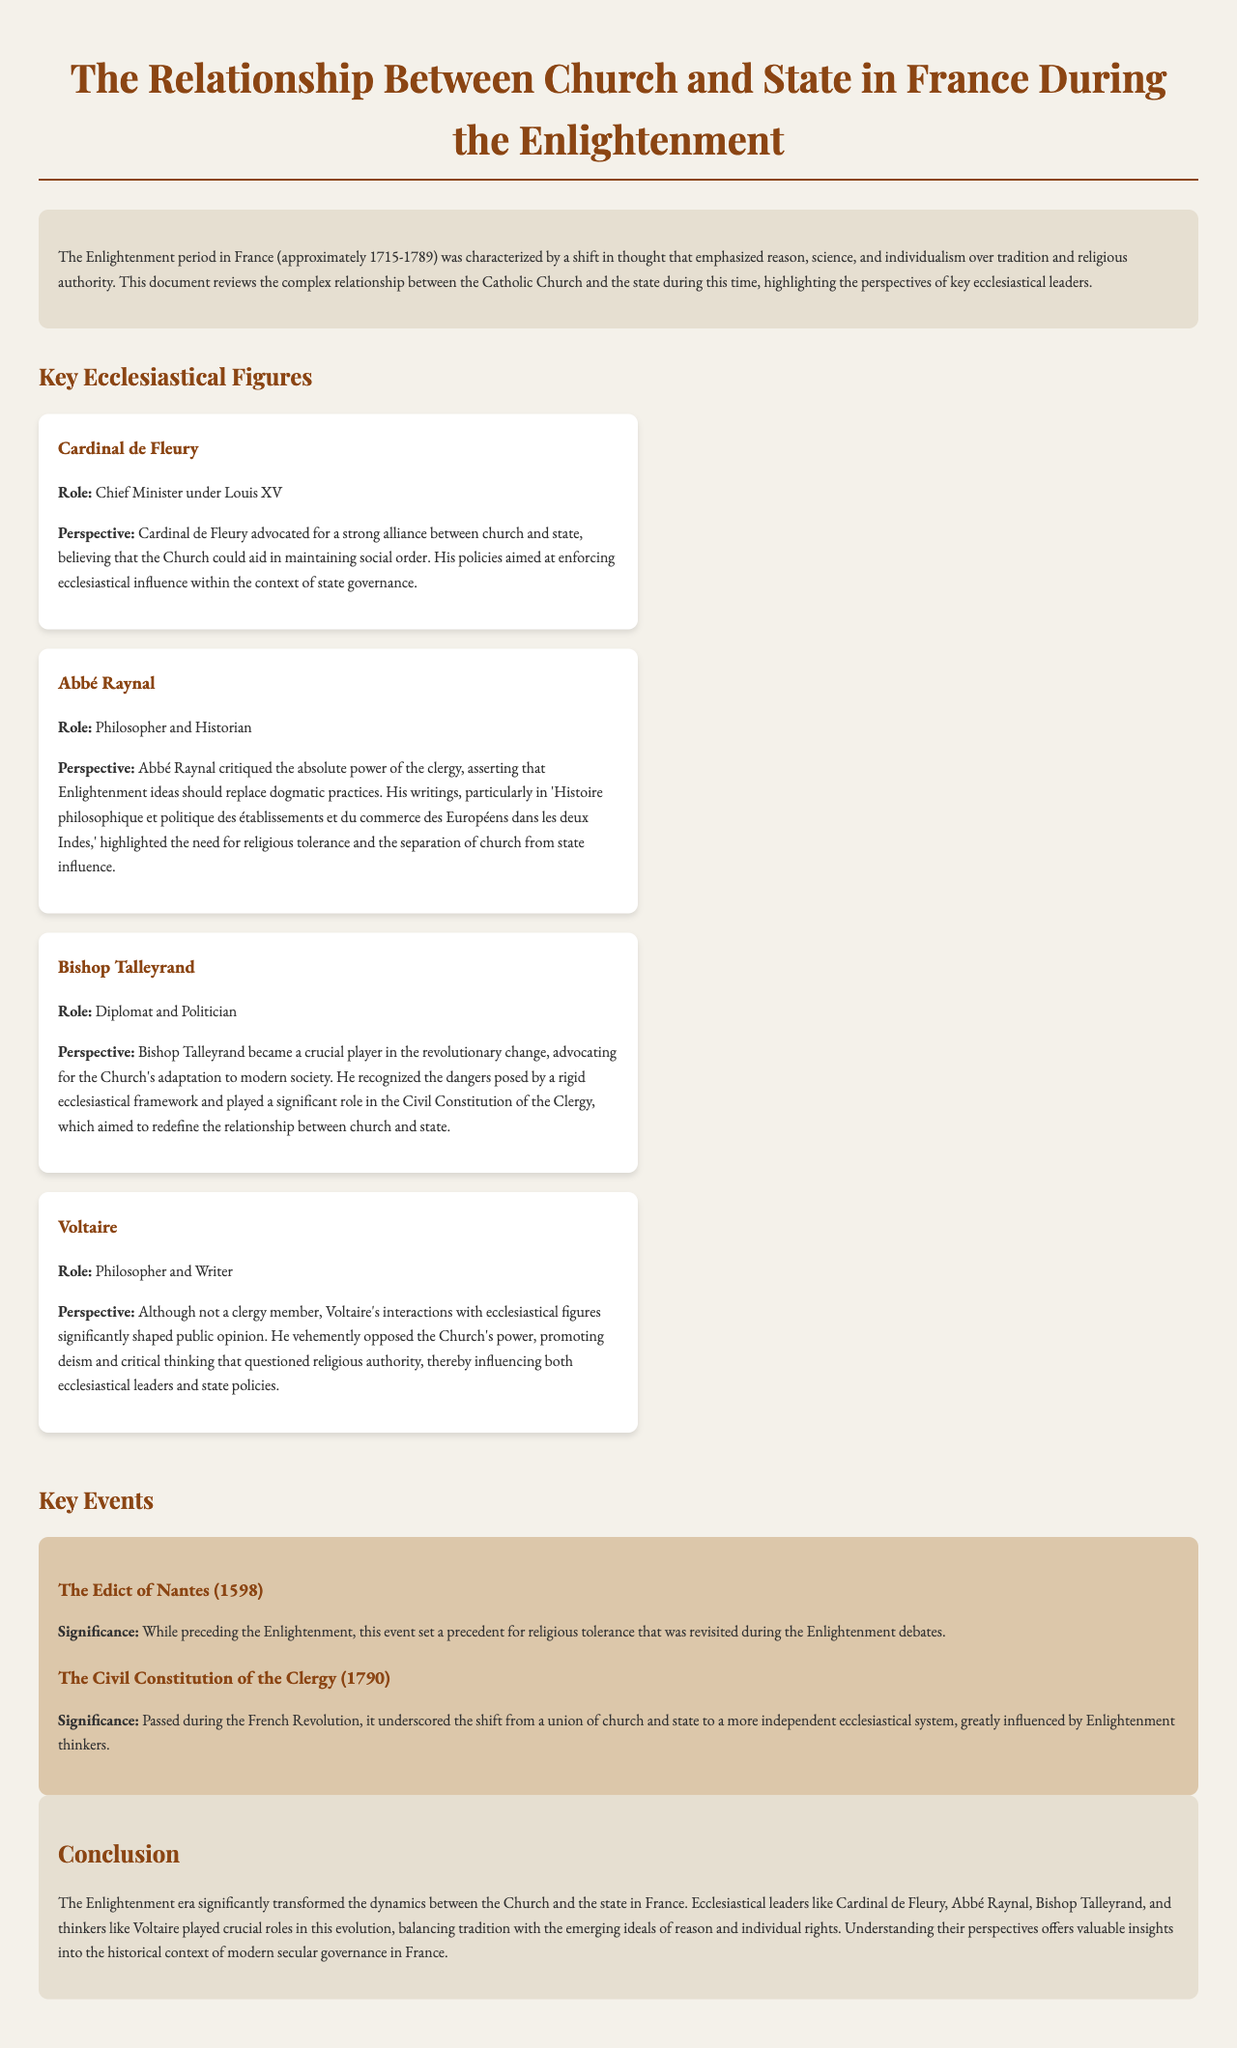What was the main period of the Enlightenment in France? The main period of the Enlightenment in France was approximately 1715-1789, as stated in the introductory paragraph.
Answer: approximately 1715-1789 Who was the Chief Minister under Louis XV? The document identifies Cardinal de Fleury as the Chief Minister under Louis XV.
Answer: Cardinal de Fleury What was the role of Abbé Raynal? Abbé Raynal is described as a philosopher and historian in the document.
Answer: Philosopher and Historian Which significant event occurred in 1790 related to church and state? The Civil Constitution of the Clergy is the key event mentioned that occurred in 1790.
Answer: The Civil Constitution of the Clergy Which ecclesiastical figure advocated for a strong alliance between church and state? The document states that Cardinal de Fleury advocated for a strong alliance between church and state.
Answer: Cardinal de Fleury What was Voltaire’s stance on the Church's power? As mentioned, Voltaire opposed the Church's power, promoting deism and critical thinking.
Answer: opposed the Church's power Which document marked a shift from a union of church and state to a more independent ecclesiastical system? The Civil Constitution of the Clergy marked this significant shift according to the document.
Answer: The Civil Constitution of the Clergy What was the main topic of the document? The main topic revolves around the relationship between church and state during the Enlightenment, as reflected in the title.
Answer: relationship between church and state What does the conclusion state about the roles of ecclesiastical leaders? The conclusion indicates that ecclesiastical leaders balanced tradition with emerging ideals of reason and individual rights.
Answer: balanced tradition with emerging ideals of reason and individual rights 